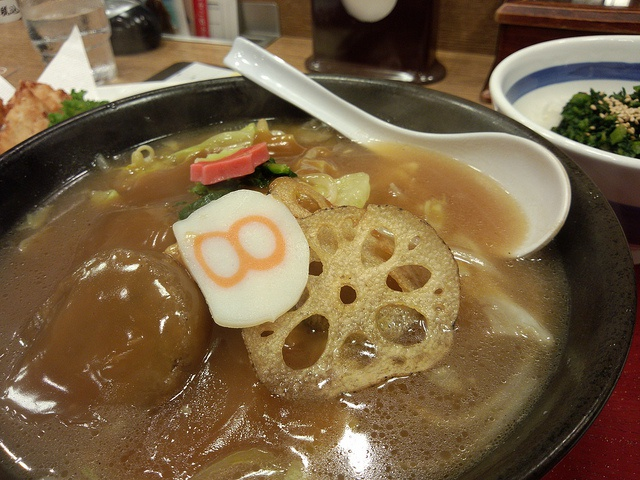Describe the objects in this image and their specific colors. I can see bowl in gray, maroon, black, tan, and olive tones, spoon in gray, darkgray, tan, olive, and beige tones, bowl in gray, darkgray, black, and beige tones, clock in gray and black tones, and cup in gray and darkgray tones in this image. 